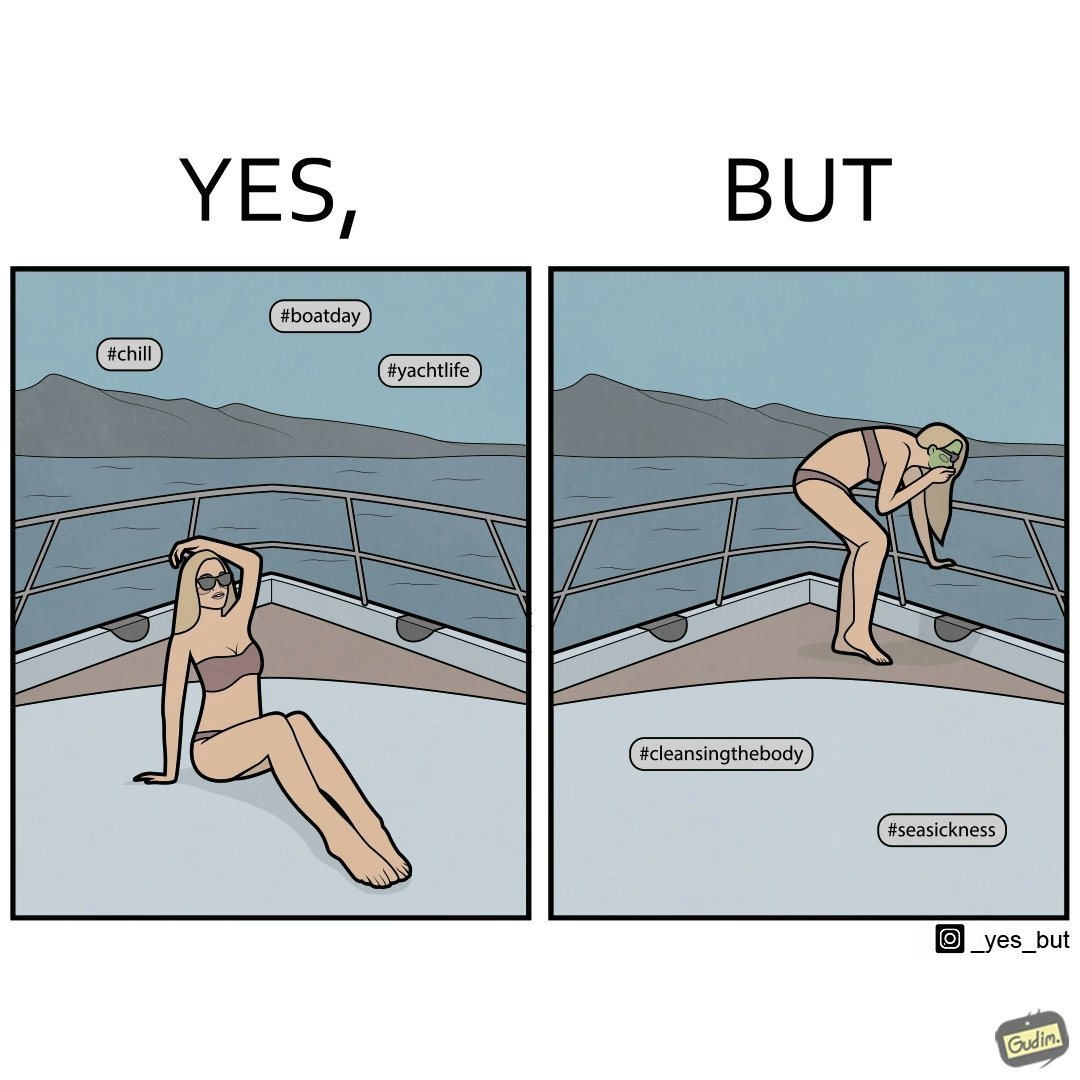What is shown in this image? The image is ironic, because in the first image the woman is showing how she is enjoying the sea trip but whereas the second image shows how she is struggling over the trip due to sea sickness which brings up a contrast comparison between the two photos 